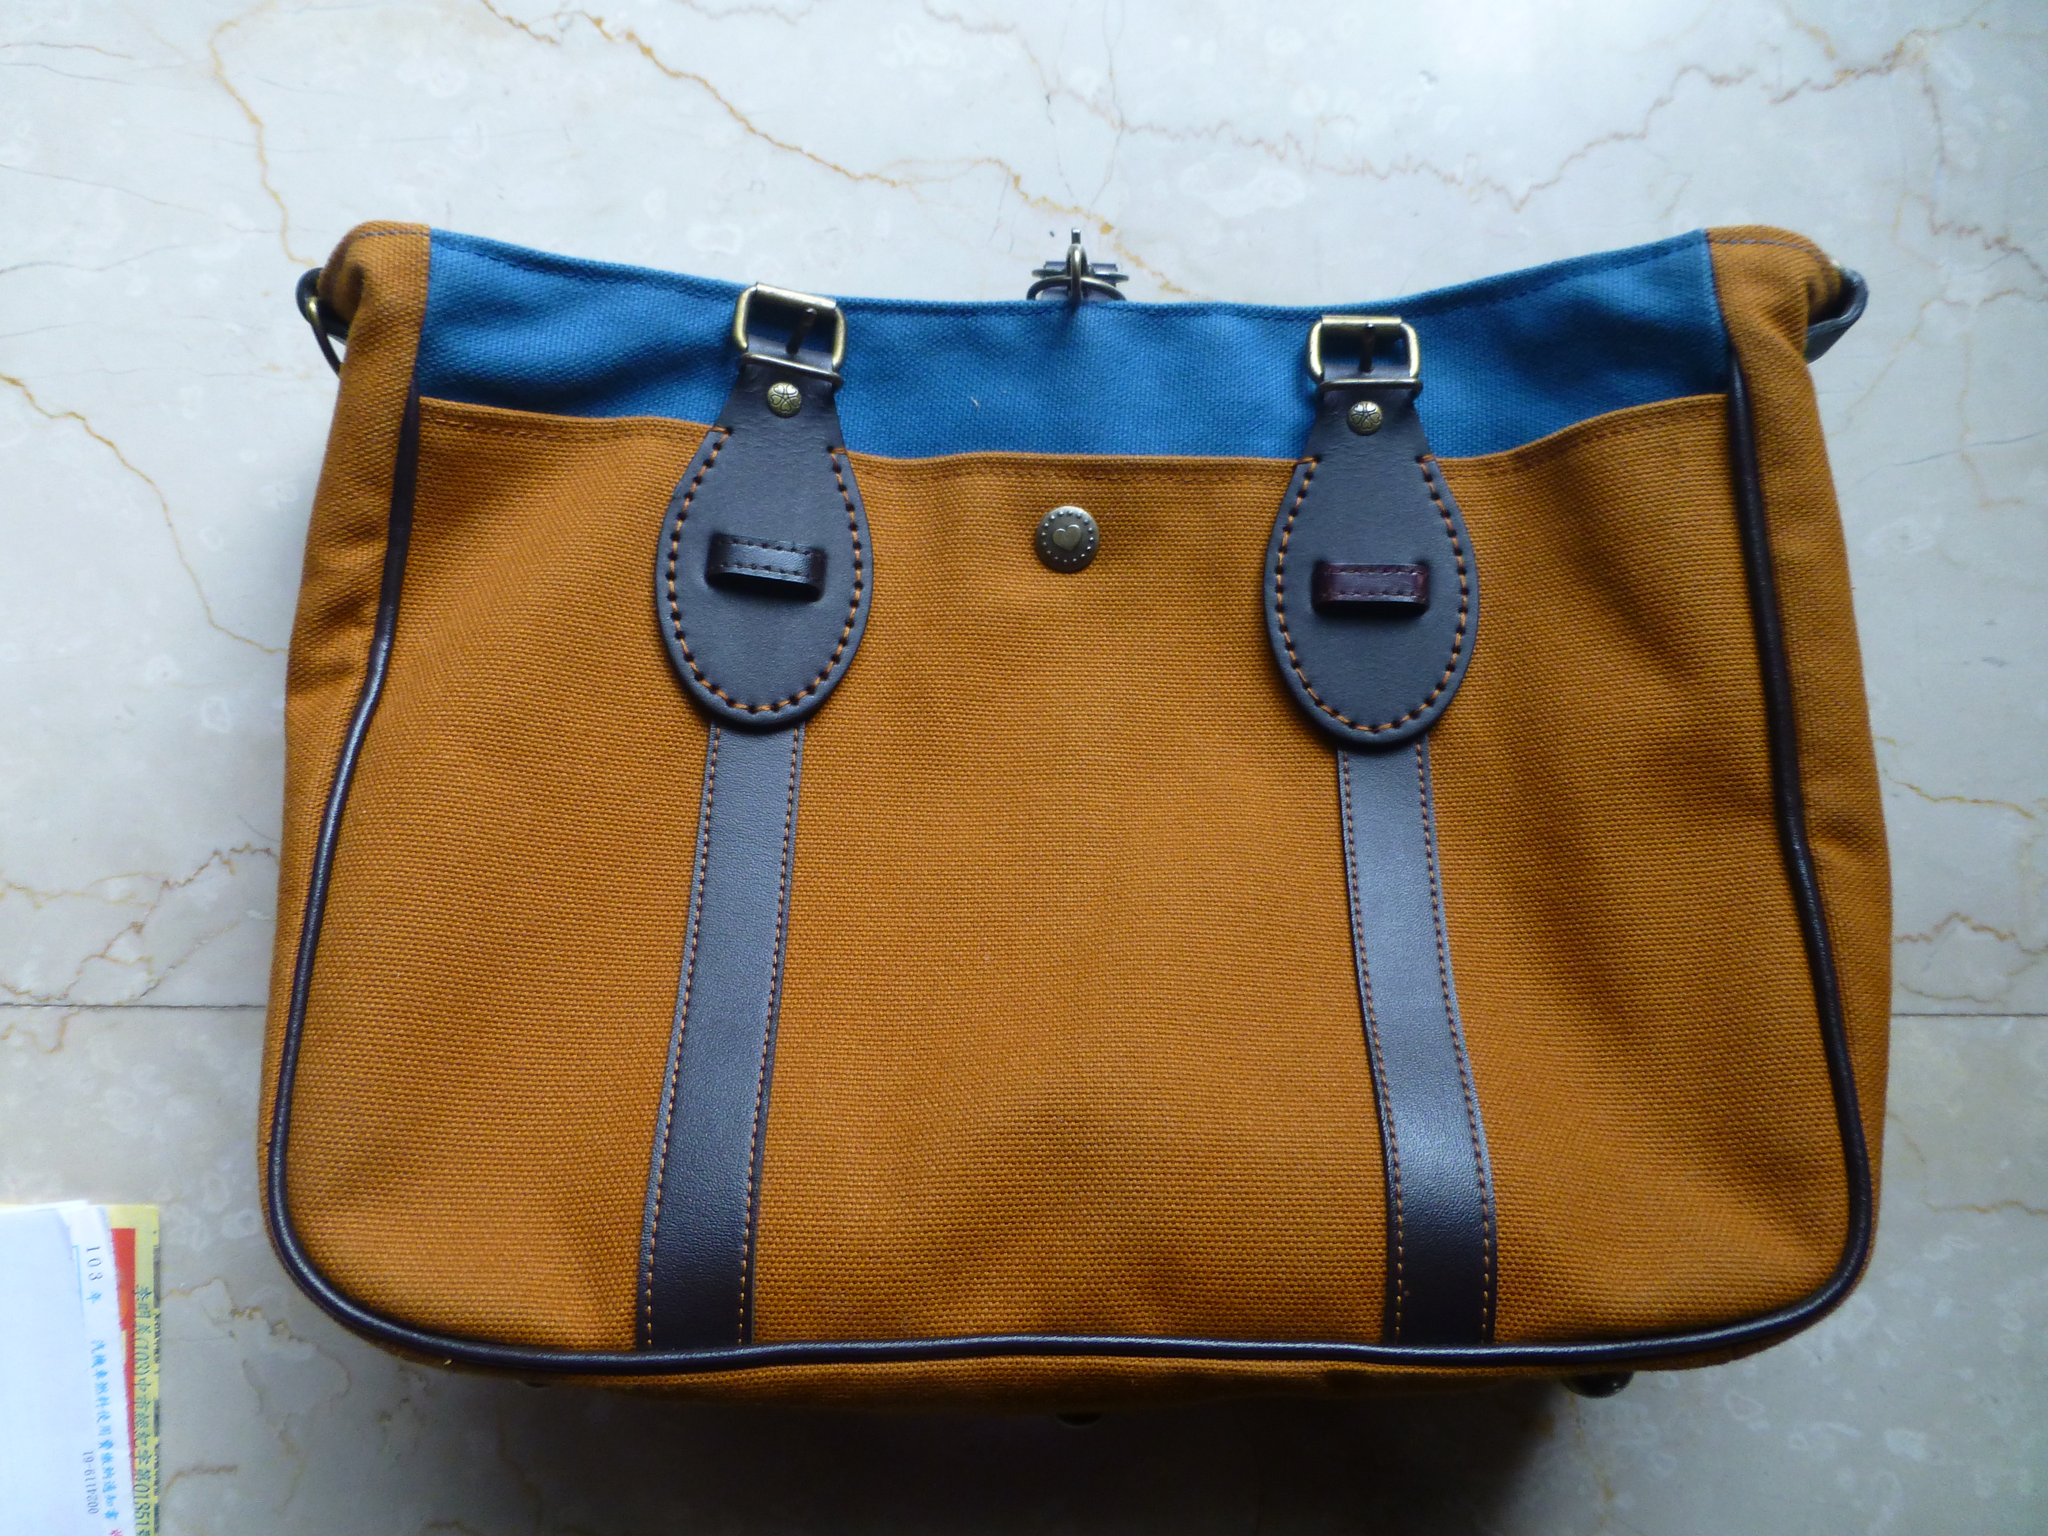Could you give a brief overview of what you see in this image? There is a bag. This is with mixed colors blue, brown and black. There is a book besides this. 